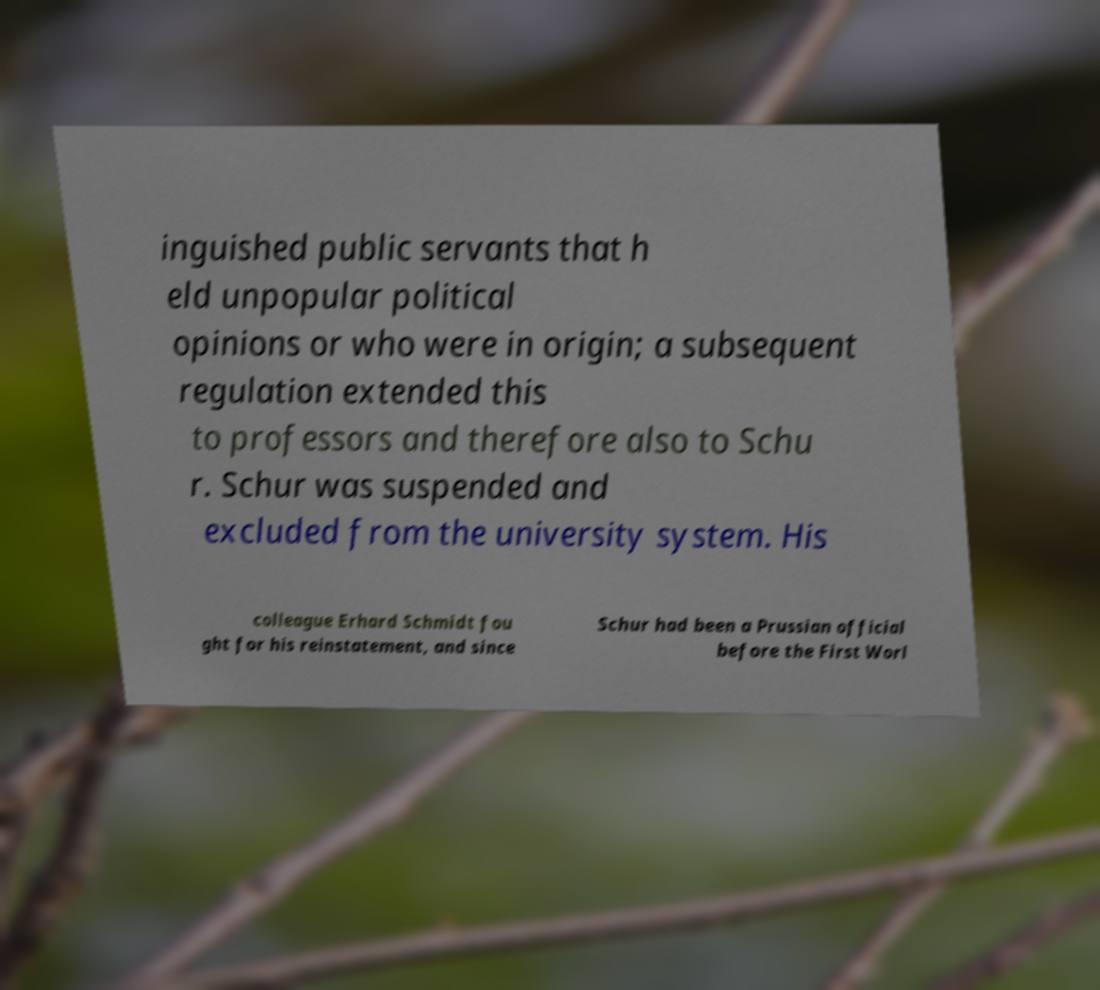Could you extract and type out the text from this image? inguished public servants that h eld unpopular political opinions or who were in origin; a subsequent regulation extended this to professors and therefore also to Schu r. Schur was suspended and excluded from the university system. His colleague Erhard Schmidt fou ght for his reinstatement, and since Schur had been a Prussian official before the First Worl 